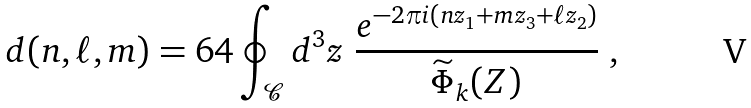<formula> <loc_0><loc_0><loc_500><loc_500>d ( n , \ell , m ) = 6 4 \oint _ { \mathcal { C } } d ^ { 3 } z \ \frac { e ^ { - 2 \pi i ( n z _ { 1 } + m z _ { 3 } + \ell z _ { 2 } ) } } { \widetilde { \Phi } _ { k } ( Z ) } \ ,</formula> 